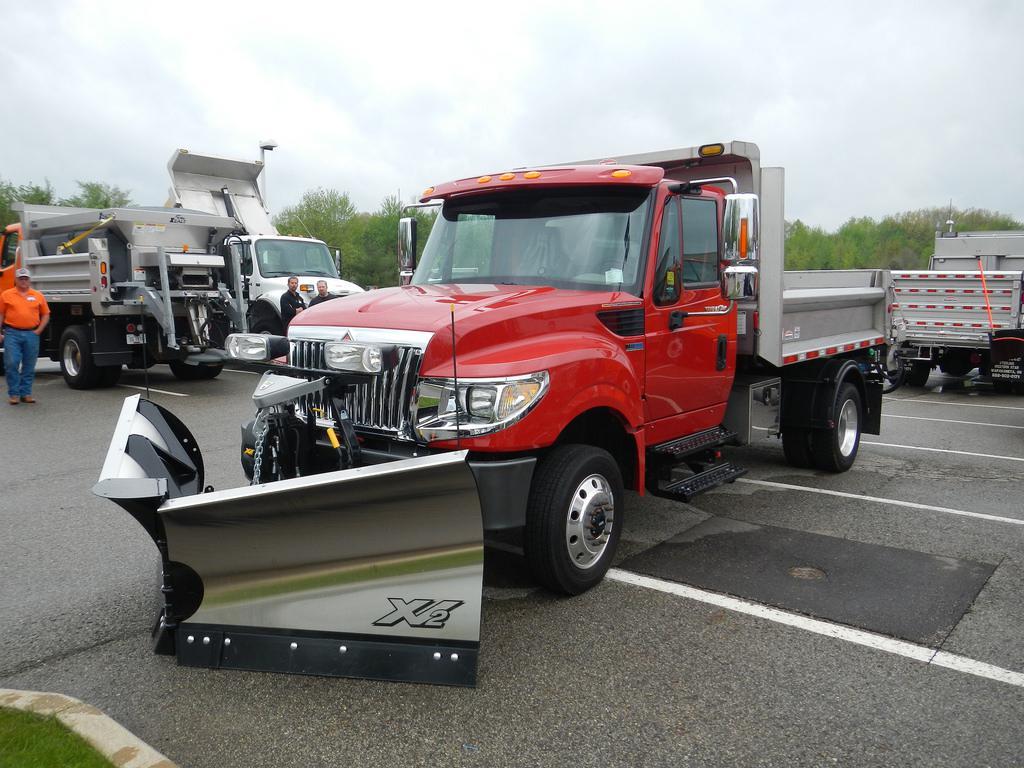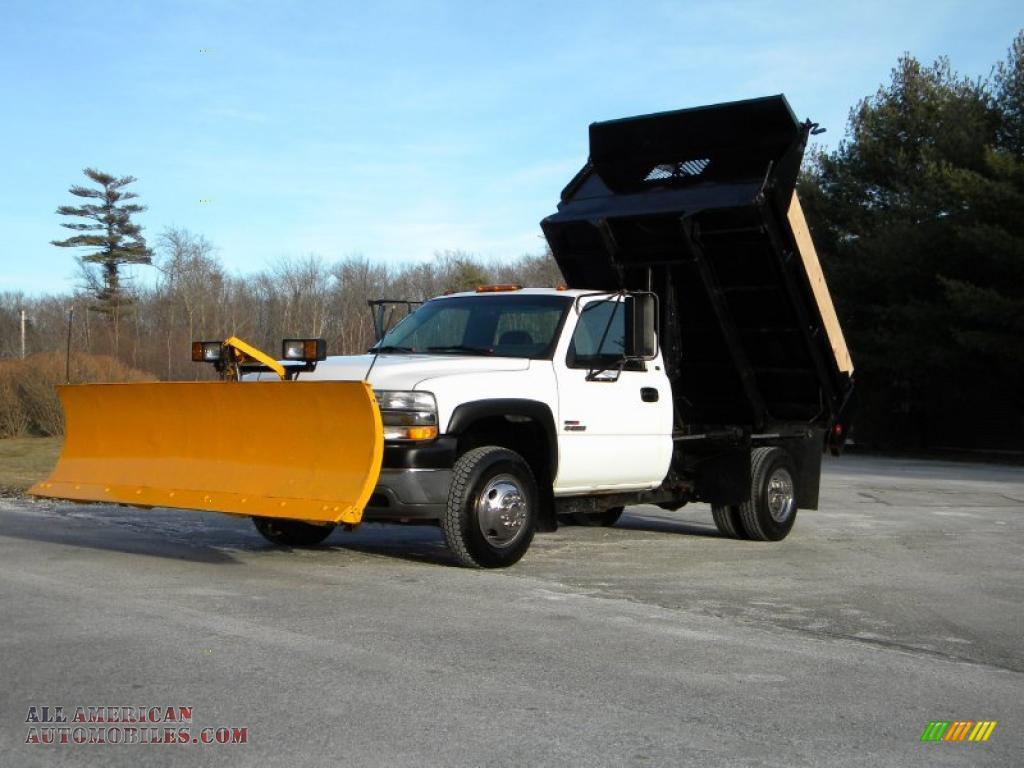The first image is the image on the left, the second image is the image on the right. Examine the images to the left and right. Is the description "All trucks have attached shovels." accurate? Answer yes or no. Yes. 